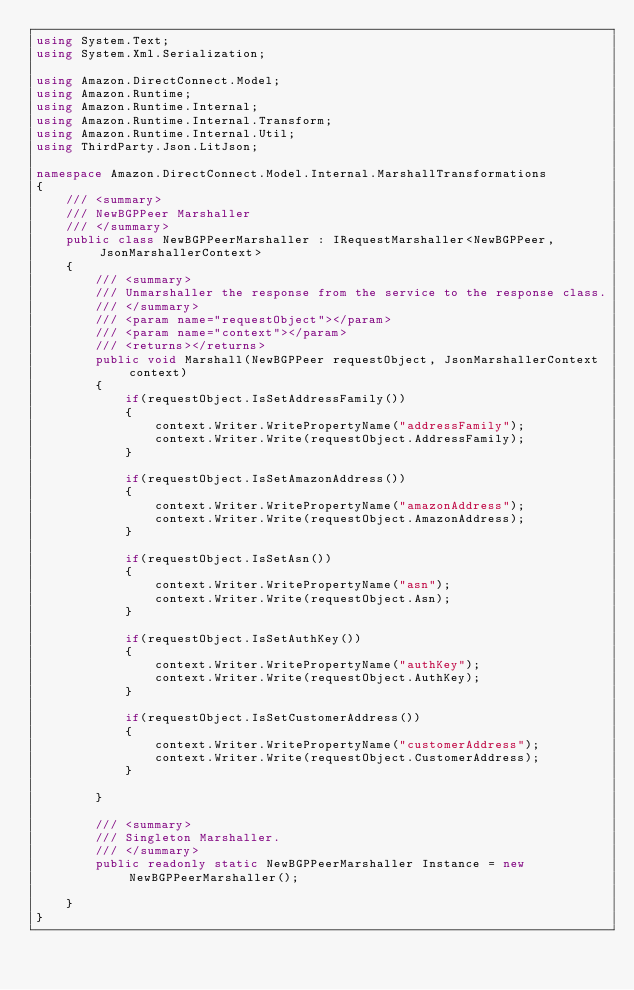Convert code to text. <code><loc_0><loc_0><loc_500><loc_500><_C#_>using System.Text;
using System.Xml.Serialization;

using Amazon.DirectConnect.Model;
using Amazon.Runtime;
using Amazon.Runtime.Internal;
using Amazon.Runtime.Internal.Transform;
using Amazon.Runtime.Internal.Util;
using ThirdParty.Json.LitJson;

namespace Amazon.DirectConnect.Model.Internal.MarshallTransformations
{
    /// <summary>
    /// NewBGPPeer Marshaller
    /// </summary>
    public class NewBGPPeerMarshaller : IRequestMarshaller<NewBGPPeer, JsonMarshallerContext> 
    {
        /// <summary>
        /// Unmarshaller the response from the service to the response class.
        /// </summary>  
        /// <param name="requestObject"></param>
        /// <param name="context"></param>
        /// <returns></returns>
        public void Marshall(NewBGPPeer requestObject, JsonMarshallerContext context)
        {
            if(requestObject.IsSetAddressFamily())
            {
                context.Writer.WritePropertyName("addressFamily");
                context.Writer.Write(requestObject.AddressFamily);
            }

            if(requestObject.IsSetAmazonAddress())
            {
                context.Writer.WritePropertyName("amazonAddress");
                context.Writer.Write(requestObject.AmazonAddress);
            }

            if(requestObject.IsSetAsn())
            {
                context.Writer.WritePropertyName("asn");
                context.Writer.Write(requestObject.Asn);
            }

            if(requestObject.IsSetAuthKey())
            {
                context.Writer.WritePropertyName("authKey");
                context.Writer.Write(requestObject.AuthKey);
            }

            if(requestObject.IsSetCustomerAddress())
            {
                context.Writer.WritePropertyName("customerAddress");
                context.Writer.Write(requestObject.CustomerAddress);
            }

        }

        /// <summary>
        /// Singleton Marshaller.
        /// </summary>
        public readonly static NewBGPPeerMarshaller Instance = new NewBGPPeerMarshaller();

    }
}</code> 